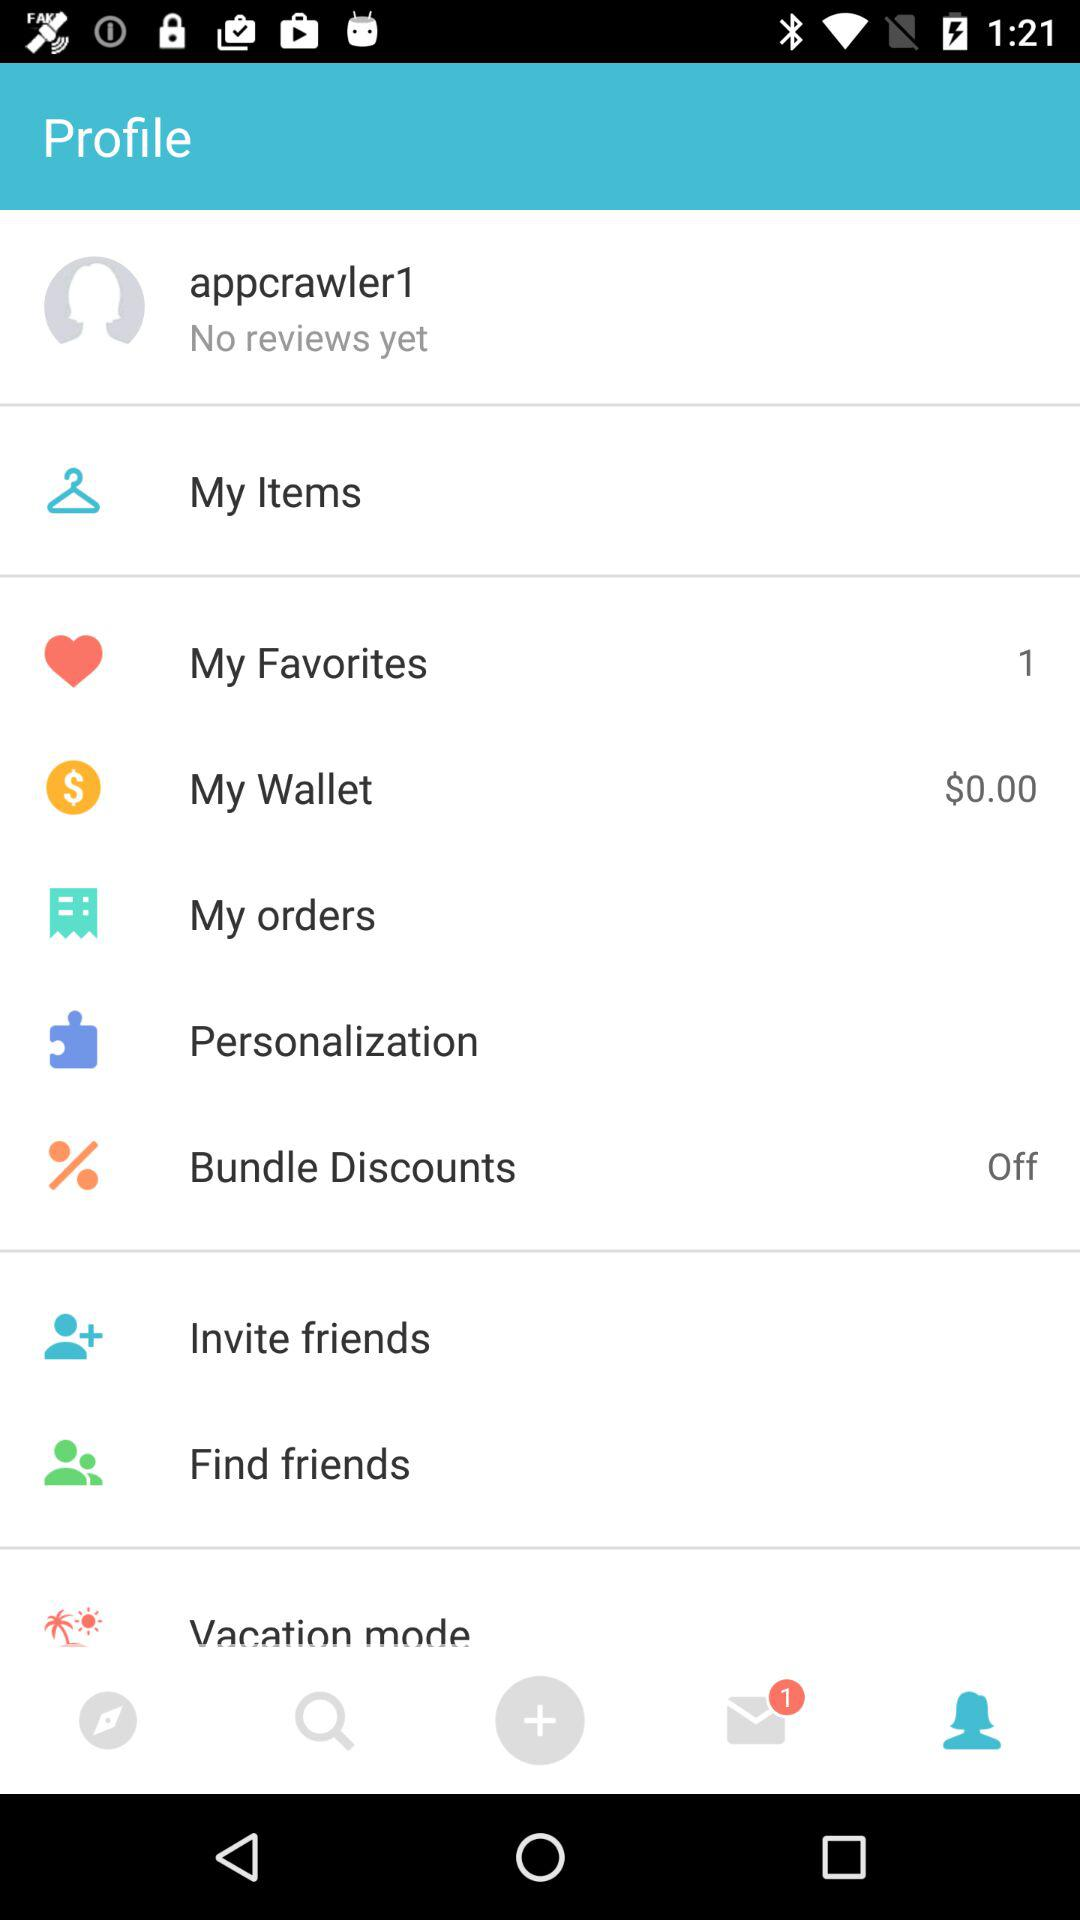Which items are listed in "My orders"?
When the provided information is insufficient, respond with <no answer>. <no answer> 